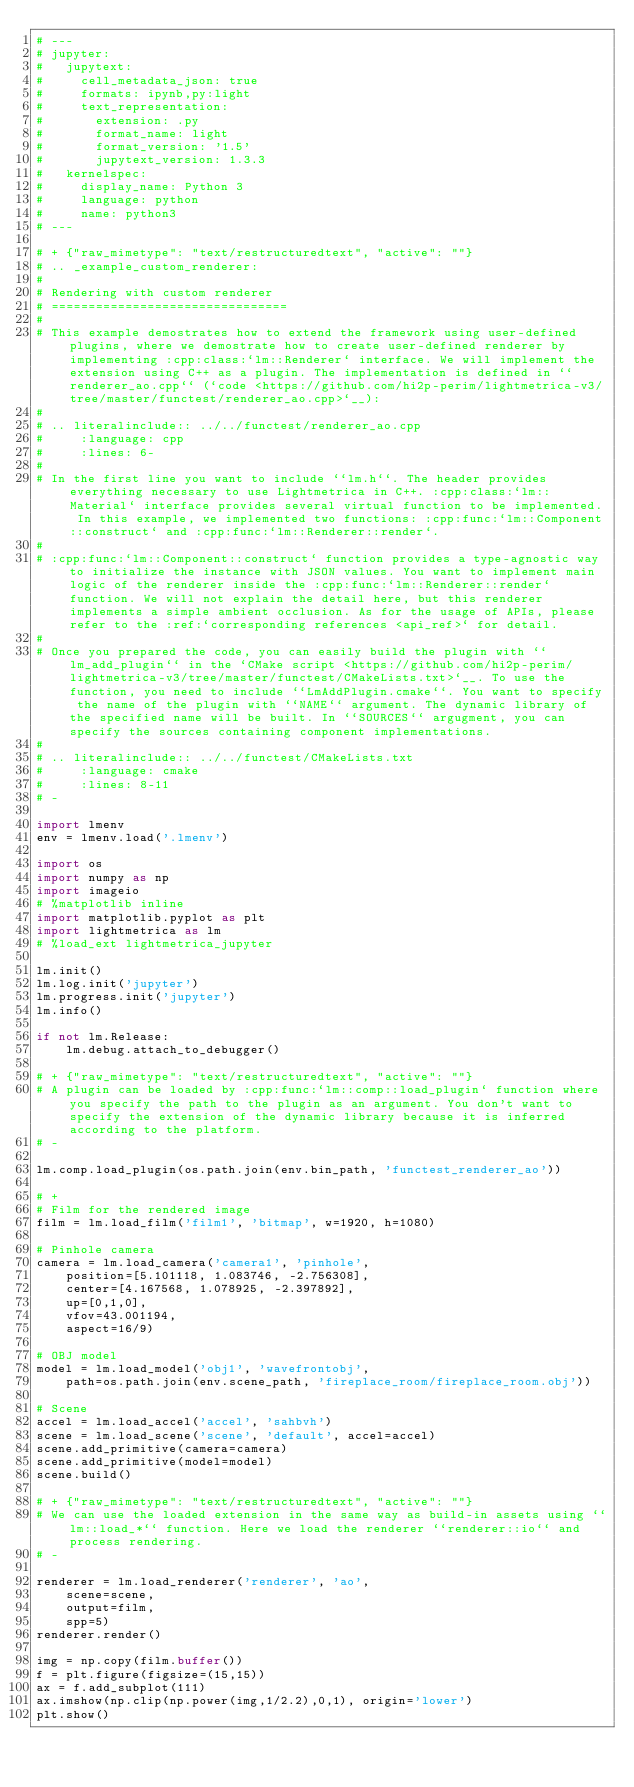Convert code to text. <code><loc_0><loc_0><loc_500><loc_500><_Python_># ---
# jupyter:
#   jupytext:
#     cell_metadata_json: true
#     formats: ipynb,py:light
#     text_representation:
#       extension: .py
#       format_name: light
#       format_version: '1.5'
#       jupytext_version: 1.3.3
#   kernelspec:
#     display_name: Python 3
#     language: python
#     name: python3
# ---

# + {"raw_mimetype": "text/restructuredtext", "active": ""}
# .. _example_custom_renderer:
#
# Rendering with custom renderer
# ================================
#
# This example demostrates how to extend the framework using user-defined plugins, where we demostrate how to create user-defined renderer by implementing :cpp:class:`lm::Renderer` interface. We will implement the extension using C++ as a plugin. The implementation is defined in ``renderer_ao.cpp`` (`code <https://github.com/hi2p-perim/lightmetrica-v3/tree/master/functest/renderer_ao.cpp>`__):
#
# .. literalinclude:: ../../functest/renderer_ao.cpp
#     :language: cpp
#     :lines: 6-
#
# In the first line you want to include ``lm.h``. The header provides everything necessary to use Lightmetrica in C++. :cpp:class:`lm::Material` interface provides several virtual function to be implemented. In this example, we implemented two functions: :cpp:func:`lm::Component::construct` and :cpp:func:`lm::Renderer::render`.
#
# :cpp:func:`lm::Component::construct` function provides a type-agnostic way to initialize the instance with JSON values. You want to implement main logic of the renderer inside the :cpp:func:`lm::Renderer::render` function. We will not explain the detail here, but this renderer implements a simple ambient occlusion. As for the usage of APIs, please refer to the :ref:`corresponding references <api_ref>` for detail.
#
# Once you prepared the code, you can easily build the plugin with ``lm_add_plugin`` in the `CMake script <https://github.com/hi2p-perim/lightmetrica-v3/tree/master/functest/CMakeLists.txt>`__. To use the function, you need to include ``LmAddPlugin.cmake``. You want to specify the name of the plugin with ``NAME`` argument. The dynamic library of the specified name will be built. In ``SOURCES`` argugment, you can specify the sources containing component implementations.
#
# .. literalinclude:: ../../functest/CMakeLists.txt
#     :language: cmake
#     :lines: 8-11
# -

import lmenv
env = lmenv.load('.lmenv')

import os
import numpy as np
import imageio
# %matplotlib inline
import matplotlib.pyplot as plt
import lightmetrica as lm
# %load_ext lightmetrica_jupyter

lm.init()
lm.log.init('jupyter')
lm.progress.init('jupyter')
lm.info()

if not lm.Release:
    lm.debug.attach_to_debugger()

# + {"raw_mimetype": "text/restructuredtext", "active": ""}
# A plugin can be loaded by :cpp:func:`lm::comp::load_plugin` function where you specify the path to the plugin as an argument. You don't want to specify the extension of the dynamic library because it is inferred according to the platform.
# -

lm.comp.load_plugin(os.path.join(env.bin_path, 'functest_renderer_ao'))

# +
# Film for the rendered image
film = lm.load_film('film1', 'bitmap', w=1920, h=1080)

# Pinhole camera
camera = lm.load_camera('camera1', 'pinhole',
    position=[5.101118, 1.083746, -2.756308],
    center=[4.167568, 1.078925, -2.397892],
    up=[0,1,0],
    vfov=43.001194,
    aspect=16/9)

# OBJ model
model = lm.load_model('obj1', 'wavefrontobj',
    path=os.path.join(env.scene_path, 'fireplace_room/fireplace_room.obj'))

# Scene
accel = lm.load_accel('accel', 'sahbvh')
scene = lm.load_scene('scene', 'default', accel=accel)
scene.add_primitive(camera=camera)
scene.add_primitive(model=model)
scene.build()

# + {"raw_mimetype": "text/restructuredtext", "active": ""}
# We can use the loaded extension in the same way as build-in assets using ``lm::load_*`` function. Here we load the renderer ``renderer::io`` and process rendering.
# -

renderer = lm.load_renderer('renderer', 'ao',
    scene=scene,
    output=film,
    spp=5)
renderer.render()

img = np.copy(film.buffer())
f = plt.figure(figsize=(15,15))
ax = f.add_subplot(111)
ax.imshow(np.clip(np.power(img,1/2.2),0,1), origin='lower')
plt.show()
</code> 